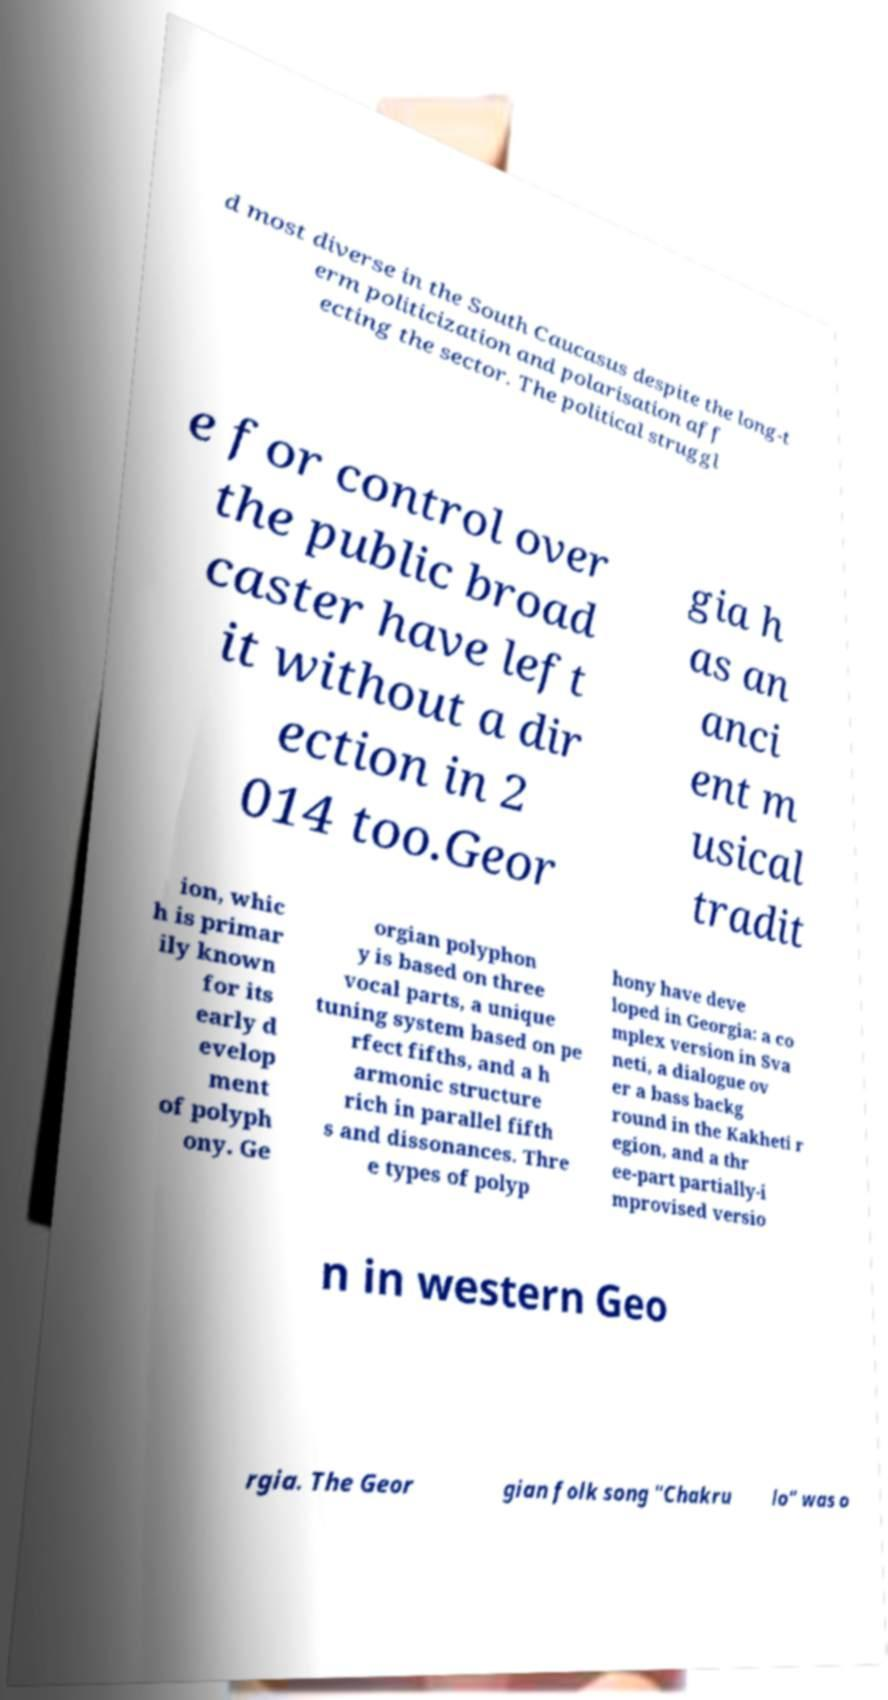Can you read and provide the text displayed in the image?This photo seems to have some interesting text. Can you extract and type it out for me? d most diverse in the South Caucasus despite the long-t erm politicization and polarisation aff ecting the sector. The political struggl e for control over the public broad caster have left it without a dir ection in 2 014 too.Geor gia h as an anci ent m usical tradit ion, whic h is primar ily known for its early d evelop ment of polyph ony. Ge orgian polyphon y is based on three vocal parts, a unique tuning system based on pe rfect fifths, and a h armonic structure rich in parallel fifth s and dissonances. Thre e types of polyp hony have deve loped in Georgia: a co mplex version in Sva neti, a dialogue ov er a bass backg round in the Kakheti r egion, and a thr ee-part partially-i mprovised versio n in western Geo rgia. The Geor gian folk song "Chakru lo" was o 